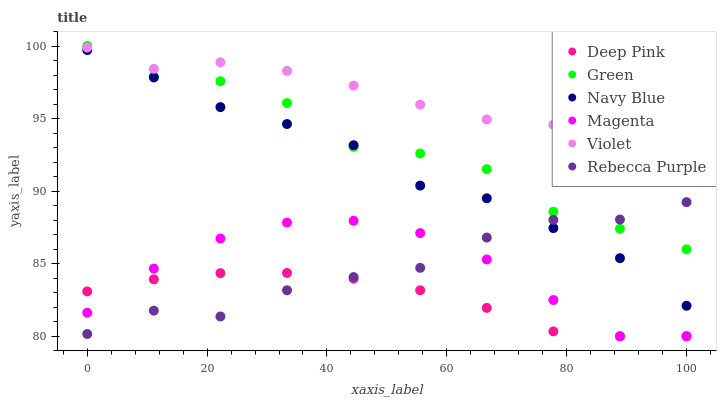Does Deep Pink have the minimum area under the curve?
Answer yes or no. Yes. Does Violet have the maximum area under the curve?
Answer yes or no. Yes. Does Navy Blue have the minimum area under the curve?
Answer yes or no. No. Does Navy Blue have the maximum area under the curve?
Answer yes or no. No. Is Deep Pink the smoothest?
Answer yes or no. Yes. Is Green the roughest?
Answer yes or no. Yes. Is Navy Blue the smoothest?
Answer yes or no. No. Is Navy Blue the roughest?
Answer yes or no. No. Does Deep Pink have the lowest value?
Answer yes or no. Yes. Does Navy Blue have the lowest value?
Answer yes or no. No. Does Green have the highest value?
Answer yes or no. Yes. Does Navy Blue have the highest value?
Answer yes or no. No. Is Navy Blue less than Violet?
Answer yes or no. Yes. Is Navy Blue greater than Magenta?
Answer yes or no. Yes. Does Navy Blue intersect Rebecca Purple?
Answer yes or no. Yes. Is Navy Blue less than Rebecca Purple?
Answer yes or no. No. Is Navy Blue greater than Rebecca Purple?
Answer yes or no. No. Does Navy Blue intersect Violet?
Answer yes or no. No. 